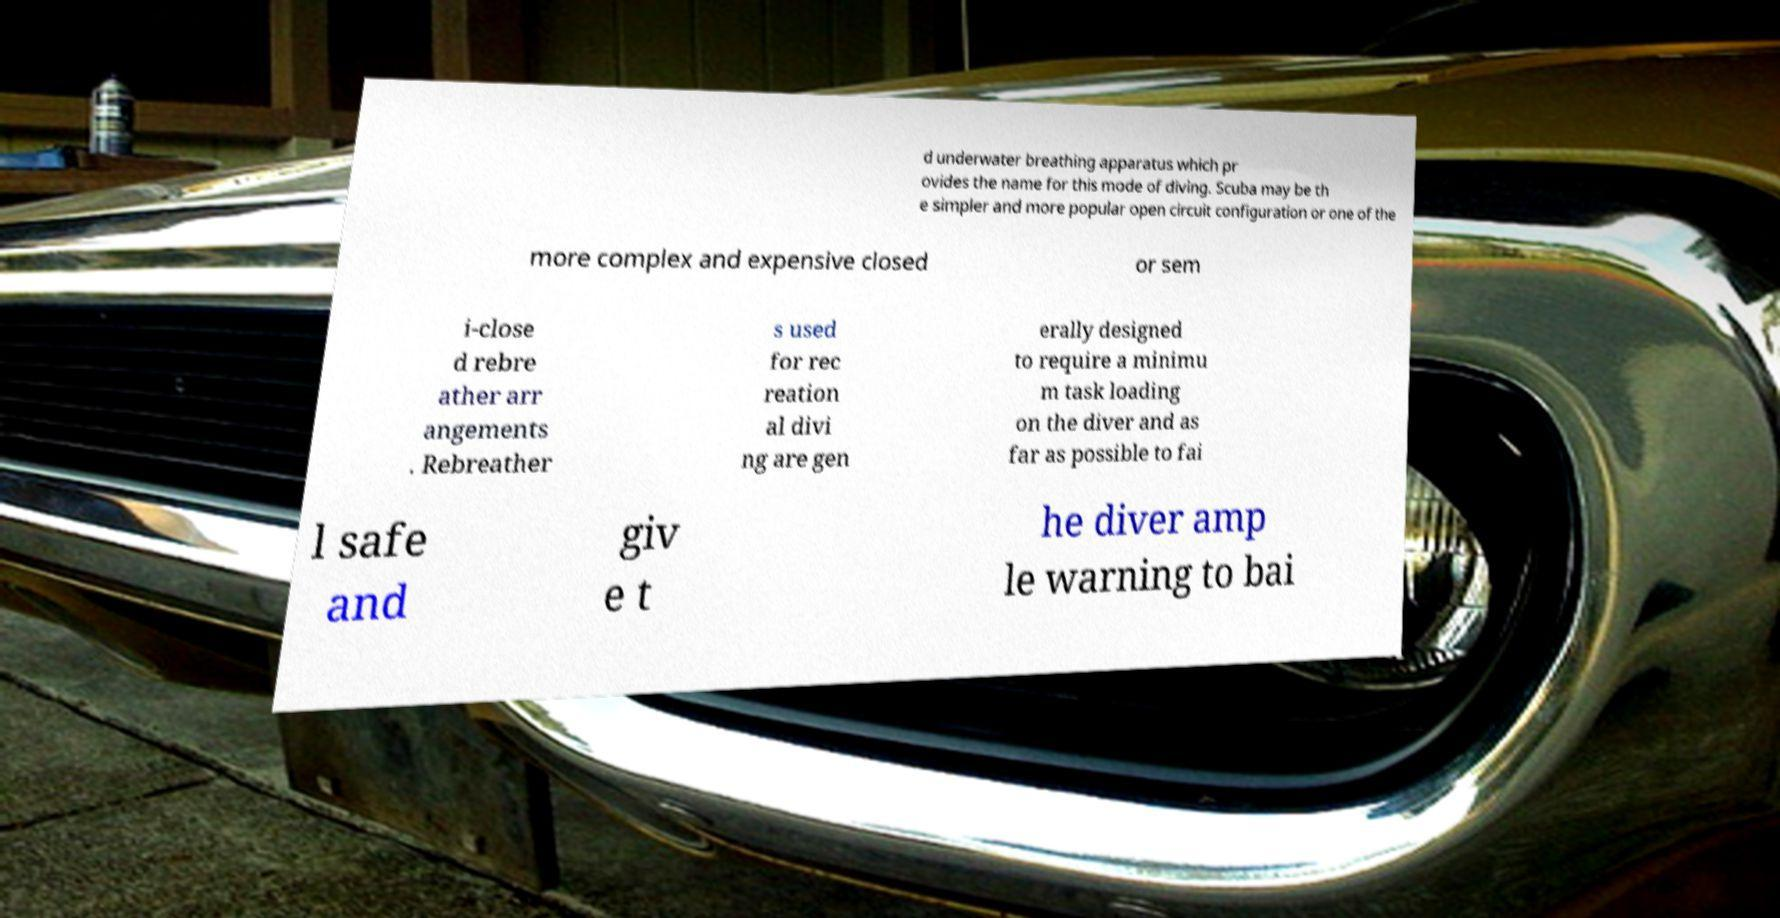Can you read and provide the text displayed in the image?This photo seems to have some interesting text. Can you extract and type it out for me? d underwater breathing apparatus which pr ovides the name for this mode of diving. Scuba may be th e simpler and more popular open circuit configuration or one of the more complex and expensive closed or sem i-close d rebre ather arr angements . Rebreather s used for rec reation al divi ng are gen erally designed to require a minimu m task loading on the diver and as far as possible to fai l safe and giv e t he diver amp le warning to bai 